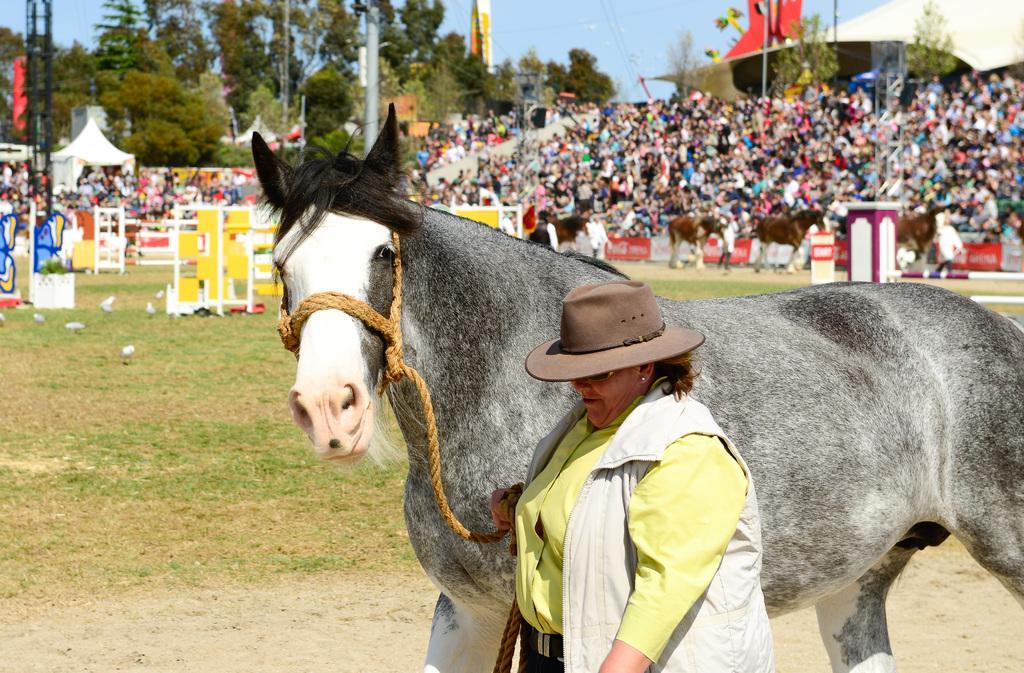Can you describe this image briefly? In this image, a horse and woman is wearing a hat. Background we can see poles, rods, hoardings, few people, horses, trees, tent and sky. 